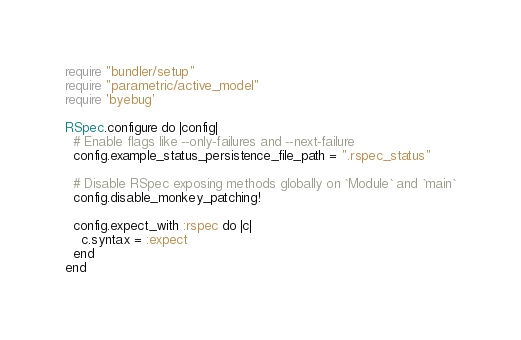<code> <loc_0><loc_0><loc_500><loc_500><_Ruby_>require "bundler/setup"
require "parametric/active_model"
require 'byebug'

RSpec.configure do |config|
  # Enable flags like --only-failures and --next-failure
  config.example_status_persistence_file_path = ".rspec_status"

  # Disable RSpec exposing methods globally on `Module` and `main`
  config.disable_monkey_patching!

  config.expect_with :rspec do |c|
    c.syntax = :expect
  end
end
</code> 